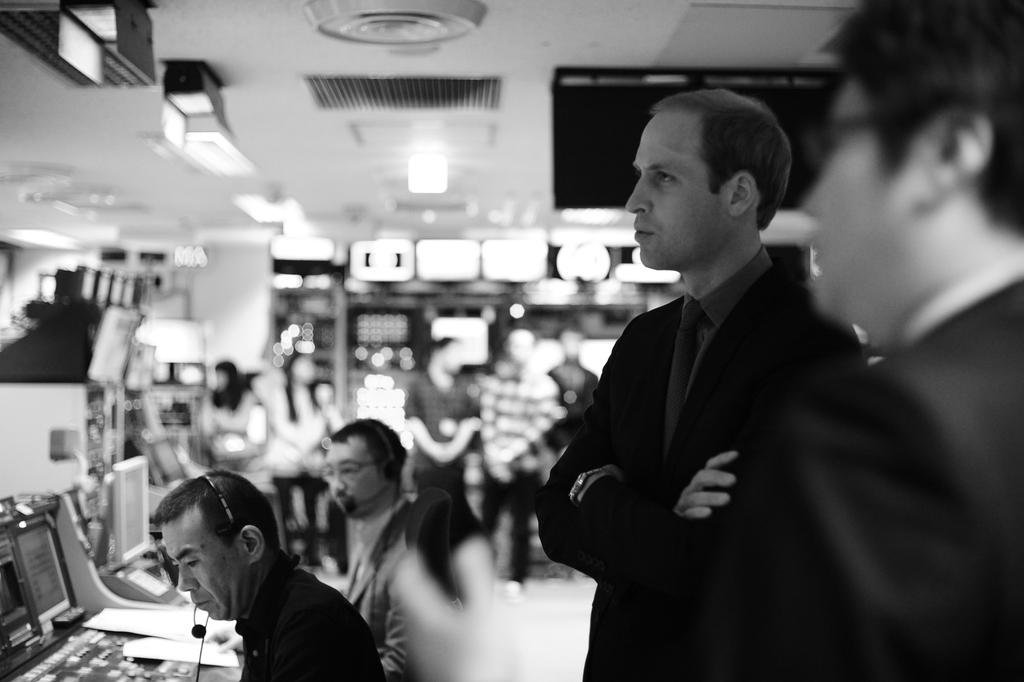Who or what can be seen in the image? There are people in the image. What else is present in the image besides the people? There are electronic gadgets and some other objects in the image. How many clovers are visible in the image? There are no clovers present in the image. What type of money can be seen in the image? There is no money visible in the image. 